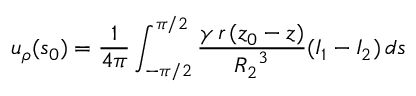<formula> <loc_0><loc_0><loc_500><loc_500>u _ { \rho } ( s _ { 0 } ) = \frac { 1 } { 4 \pi } \int _ { - \pi / 2 } ^ { \pi / 2 } \frac { \gamma \, r \, ( z _ { 0 } - z ) } { { R _ { 2 } } ^ { 3 } } ( I _ { 1 } - I _ { 2 } ) \, d s</formula> 